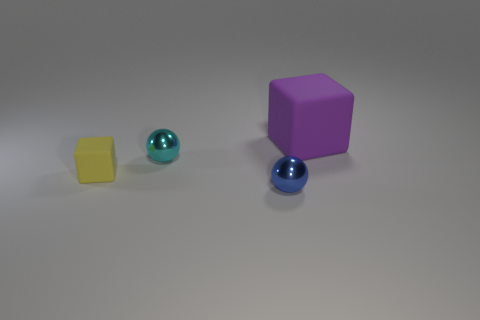Add 4 things. How many objects exist? 8 Subtract all tiny yellow rubber cubes. Subtract all cyan shiny spheres. How many objects are left? 2 Add 3 matte cubes. How many matte cubes are left? 5 Add 4 tiny gray balls. How many tiny gray balls exist? 4 Subtract 0 yellow spheres. How many objects are left? 4 